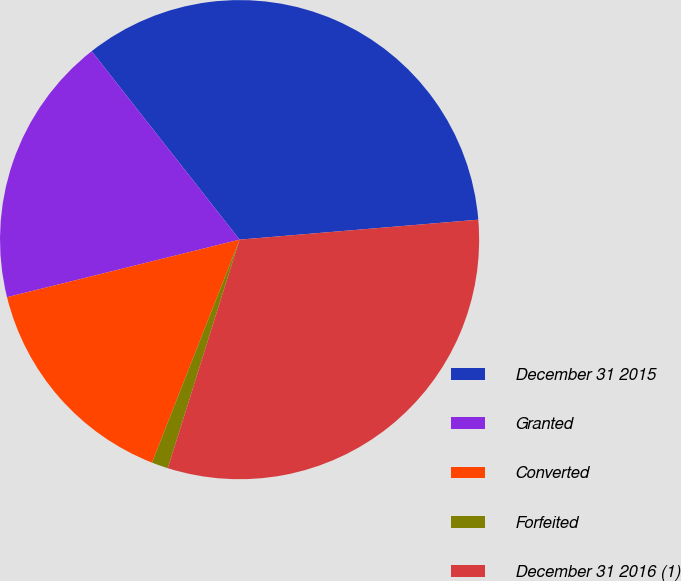Convert chart to OTSL. <chart><loc_0><loc_0><loc_500><loc_500><pie_chart><fcel>December 31 2015<fcel>Granted<fcel>Converted<fcel>Forfeited<fcel>December 31 2016 (1)<nl><fcel>34.26%<fcel>18.27%<fcel>15.18%<fcel>1.11%<fcel>31.17%<nl></chart> 